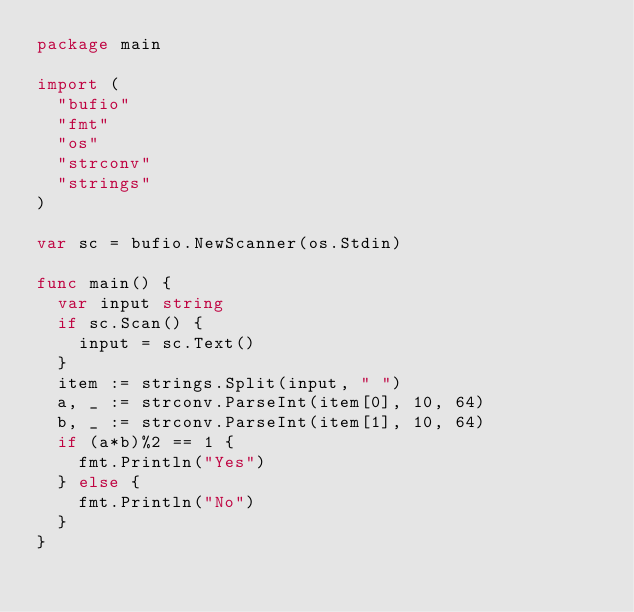Convert code to text. <code><loc_0><loc_0><loc_500><loc_500><_Go_>package main

import (
	"bufio"
	"fmt"
	"os"
	"strconv"
	"strings"
)

var sc = bufio.NewScanner(os.Stdin)

func main() {
	var input string
	if sc.Scan() {
		input = sc.Text()
	}
	item := strings.Split(input, " ")
	a, _ := strconv.ParseInt(item[0], 10, 64)
	b, _ := strconv.ParseInt(item[1], 10, 64)
	if (a*b)%2 == 1 {
		fmt.Println("Yes")
	} else {
		fmt.Println("No")
	}
}
</code> 